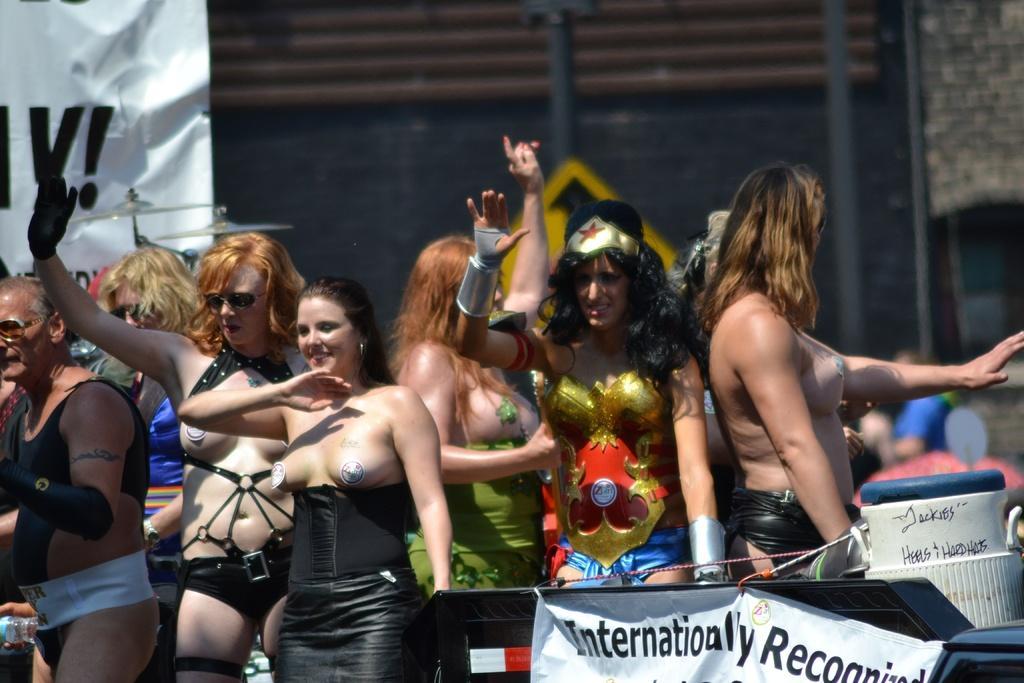Can you describe this image briefly? This image is taken outdoors. At the bottom of the image there is a vehicle and a board with text on it. In the background there is a wall and a board with text on it. In the middle of the image there are a few women standing on the road with smiling faces. 